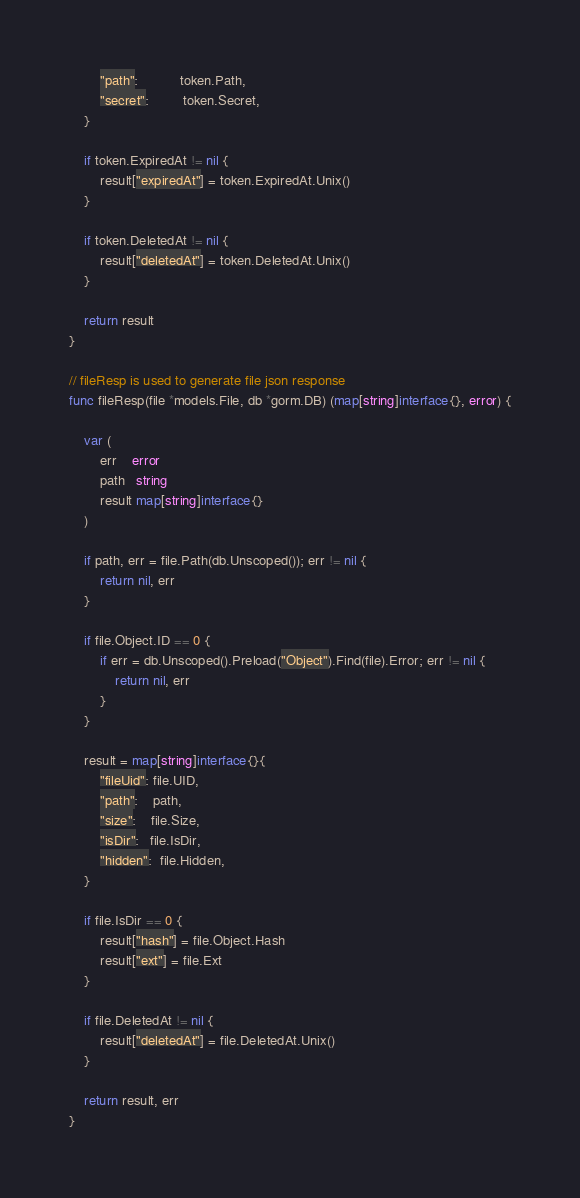<code> <loc_0><loc_0><loc_500><loc_500><_Go_>		"path":           token.Path,
		"secret":         token.Secret,
	}

	if token.ExpiredAt != nil {
		result["expiredAt"] = token.ExpiredAt.Unix()
	}

	if token.DeletedAt != nil {
		result["deletedAt"] = token.DeletedAt.Unix()
	}

	return result
}

// fileResp is used to generate file json response
func fileResp(file *models.File, db *gorm.DB) (map[string]interface{}, error) {

	var (
		err    error
		path   string
		result map[string]interface{}
	)

	if path, err = file.Path(db.Unscoped()); err != nil {
		return nil, err
	}

	if file.Object.ID == 0 {
		if err = db.Unscoped().Preload("Object").Find(file).Error; err != nil {
			return nil, err
		}
	}

	result = map[string]interface{}{
		"fileUid": file.UID,
		"path":    path,
		"size":    file.Size,
		"isDir":   file.IsDir,
		"hidden":  file.Hidden,
	}

	if file.IsDir == 0 {
		result["hash"] = file.Object.Hash
		result["ext"] = file.Ext
	}

	if file.DeletedAt != nil {
		result["deletedAt"] = file.DeletedAt.Unix()
	}

	return result, err
}
</code> 